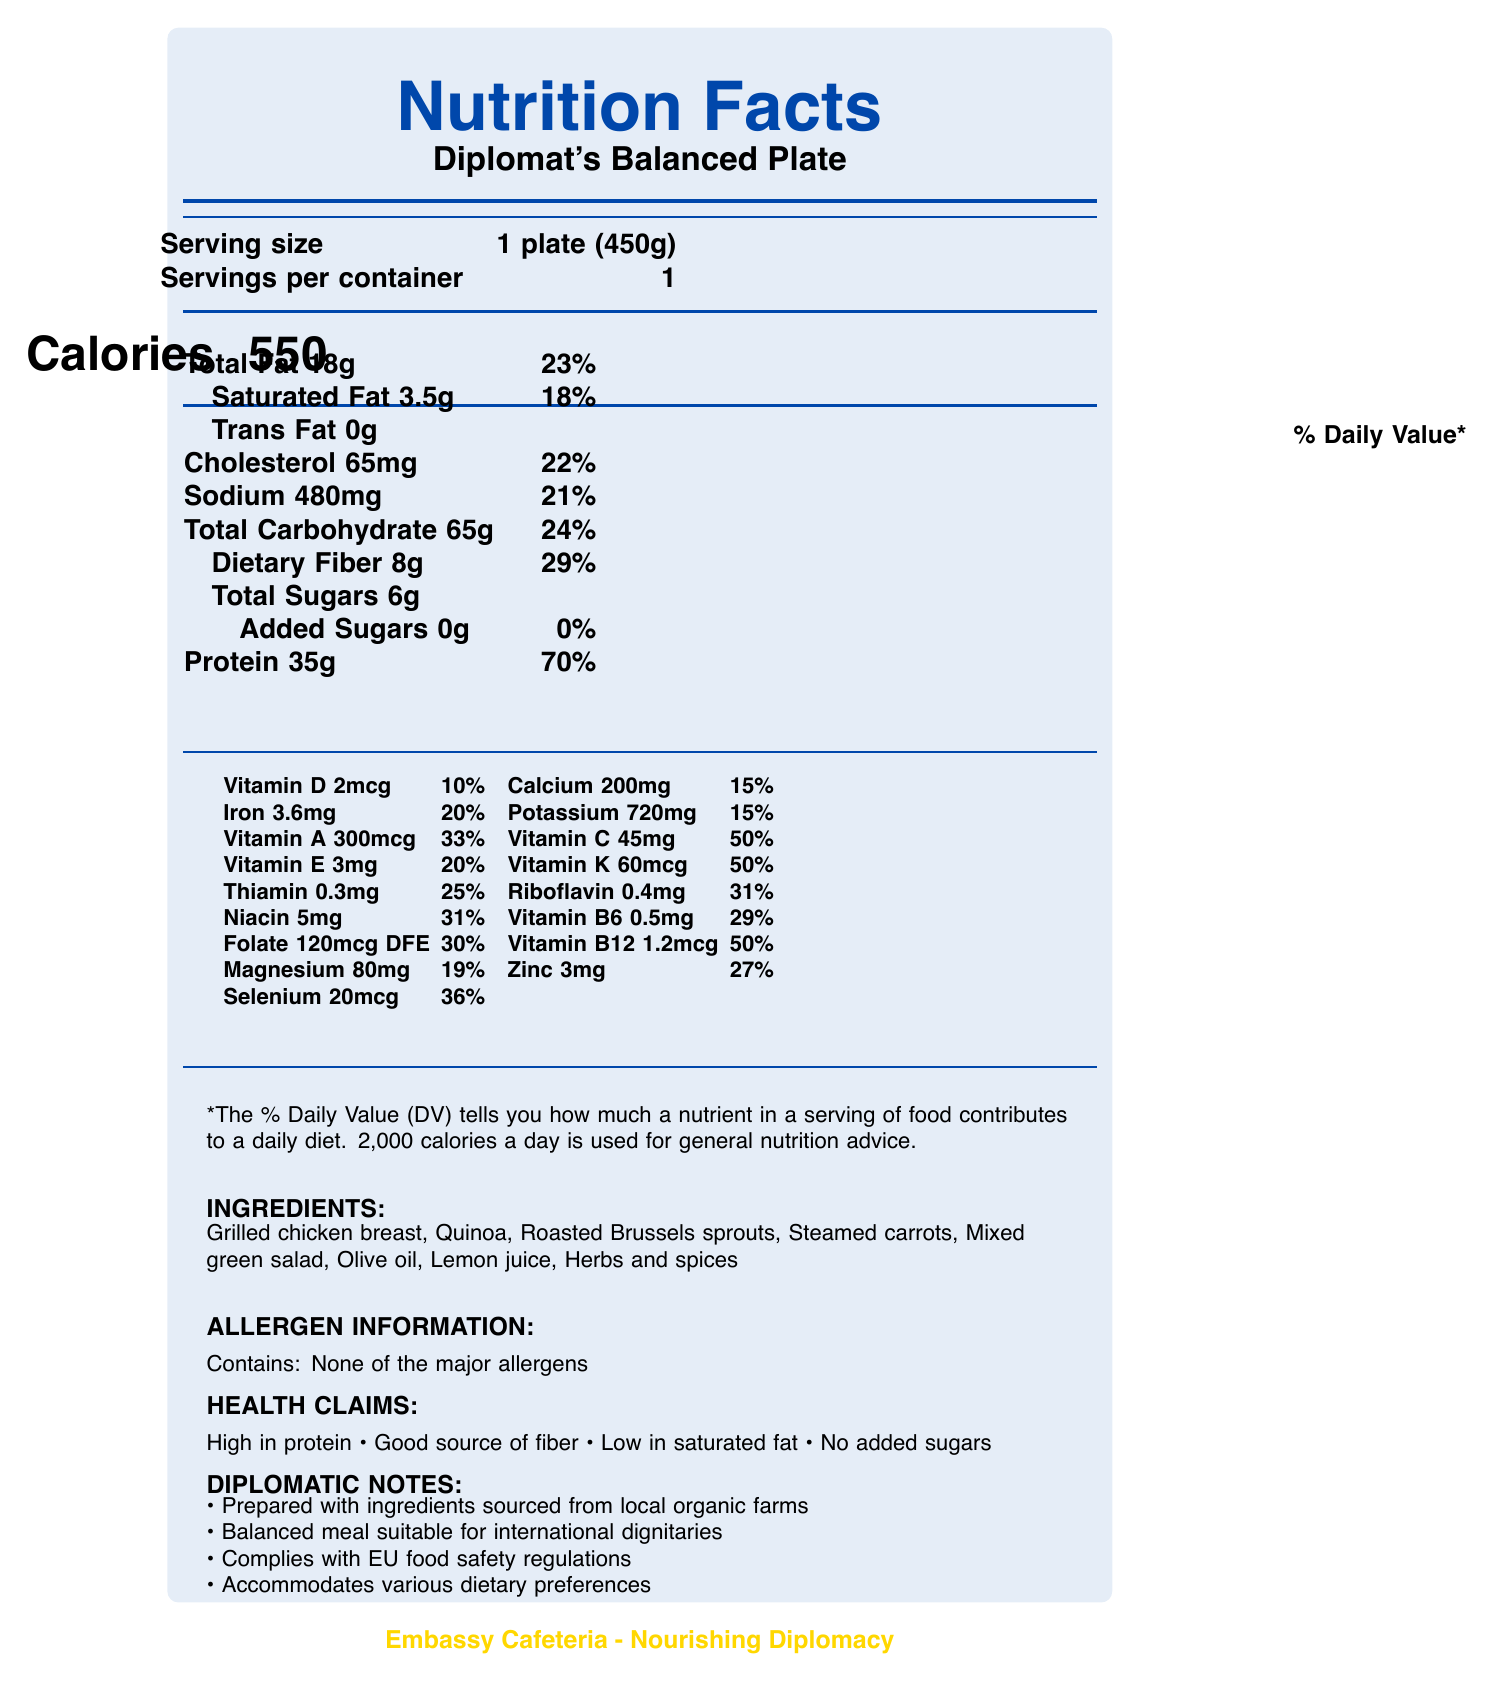what is the serving size for the Diplomat's Balanced Plate? The document specifies the serving size as 1 plate (450g).
Answer: 1 plate (450g) how many calories are in one serving size? The document clearly states that there are 550 calories per serving size.
Answer: 550 how much total fat is in the Diplomat's Balanced Plate? The total fat content is listed as 18g in the document.
Answer: 18g what is the amount and daily value percentage of dietary fiber? The document lists dietary fiber as 8g, which is 29% of the daily value.
Answer: 8g, 29% which vitamin has the highest daily value percentage? Vitamin C has a daily value of 50%, which is the highest among the listed vitamins.
Answer: Vitamin C which of the following components has 0 grams? A. Saturated Fat B. Cholesterol C. Trans Fat D. Added Sugars Trans Fat is listed as 0g in the document.
Answer: C how much protein is in the meal, and what percentage of the daily value does that represent? The document states that the meal contains 35g of protein, which represents 70% of the daily value.
Answer: 35g, 70% what ingredients are used in the Diplomat's Balanced Plate? The document provides a list of ingredients: Grilled chicken breast, Quinoa, Roasted Brussels sprouts, Steamed carrots, Mixed green salad, Olive oil, Lemon juice, and Herbs and spices.
Answer: Grilled chicken breast, Quinoa, Roasted Brussels sprouts, Steamed carrots, Mixed green salad, Olive oil, Lemon juice, Herbs, and spices does the meal contain any added sugars? The document explicitly states that the meal contains 0g of added sugars.
Answer: No true or false: the meal is high in protein and good source of fiber The document lists "High in protein" and "Good source of fiber" under health claims.
Answer: True what is the amount of sodium in this meal, and how does it compare to the daily value percentage? The sodium content is 480mg, which is 21% of the daily value.
Answer: 480mg, 21% summary: describe the main attributes of the Diplomat's Balanced Plate based on the document The main attributes described in the document include nutritional content, ingredient details, health claims, allergen information, and compliance with safety regulations.
Answer: The Diplomat's Balanced Plate is a balanced meal designed for health-conscious individuals, containing 550 calories per 450g serving. It includes 18g of total fat, 65g of carbohydrates, and 35g of protein. The meal is enriched with various vitamins and minerals, including Vitamin C (50% DV) and Vitamin K (50% DV). It is prepared with ingredients such as Grilled chicken breast, Quinoa, and Mixed green salad, and contains no major allergens or added sugars. The meal complies with EU food safety regulations and is suitable for international dignitaries. how does the meal accommodate various dietary preferences? The document mentions that the meal accommodates various dietary preferences but does not provide specific details on how this is achieved.
Answer: Cannot be determined 